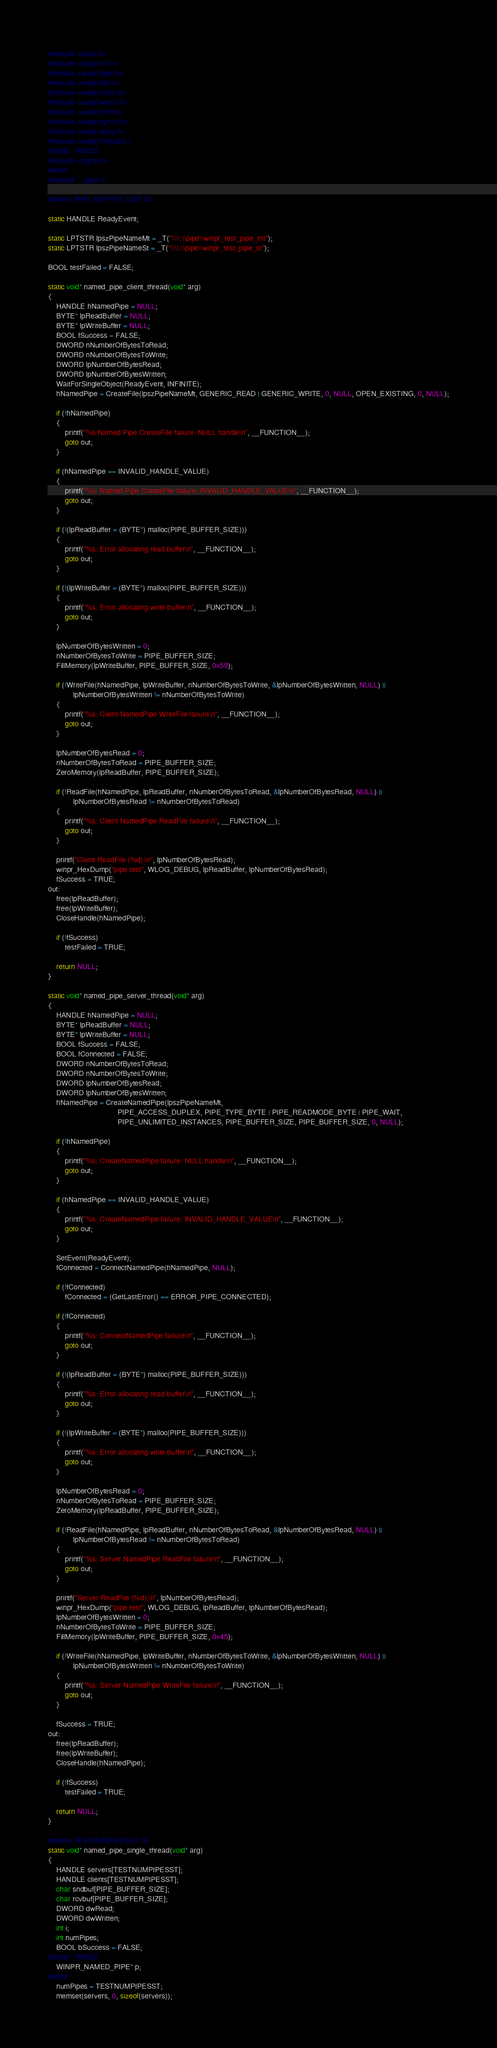<code> <loc_0><loc_0><loc_500><loc_500><_C_>
#include <stdio.h>
#include <winpr/crt.h>
#include <winpr/pipe.h>
#include <winpr/file.h>
#include <winpr/tchar.h>
#include <winpr/winpr.h>
#include <winpr/print.h>
#include <winpr/synch.h>
#include <winpr/wlog.h>
#include <winpr/thread.h>
#ifndef _WIN32
#include <signal.h>
#endif
#include "../pipe.h"

#define PIPE_BUFFER_SIZE	32

static HANDLE ReadyEvent;

static LPTSTR lpszPipeNameMt = _T("\\\\.\\pipe\\winpr_test_pipe_mt");
static LPTSTR lpszPipeNameSt = _T("\\\\.\\pipe\\winpr_test_pipe_st");

BOOL testFailed = FALSE;

static void* named_pipe_client_thread(void* arg)
{
	HANDLE hNamedPipe = NULL;
	BYTE* lpReadBuffer = NULL;
	BYTE* lpWriteBuffer = NULL;
	BOOL fSuccess = FALSE;
	DWORD nNumberOfBytesToRead;
	DWORD nNumberOfBytesToWrite;
	DWORD lpNumberOfBytesRead;
	DWORD lpNumberOfBytesWritten;
	WaitForSingleObject(ReadyEvent, INFINITE);
	hNamedPipe = CreateFile(lpszPipeNameMt, GENERIC_READ | GENERIC_WRITE, 0, NULL, OPEN_EXISTING, 0, NULL);

	if (!hNamedPipe)
	{
		printf("%s:Named Pipe CreateFile failure: NULL handle\n", __FUNCTION__);
		goto out;
	}

	if (hNamedPipe == INVALID_HANDLE_VALUE)
	{
		printf("%s: Named Pipe CreateFile failure: INVALID_HANDLE_VALUE\n", __FUNCTION__);
		goto out;
	}

	if (!(lpReadBuffer = (BYTE*) malloc(PIPE_BUFFER_SIZE)))
	{
		printf("%s: Error allocating read buffer\n", __FUNCTION__);
		goto out;
	}

	if (!(lpWriteBuffer = (BYTE*) malloc(PIPE_BUFFER_SIZE)))
	{
		printf("%s: Error allocating write buffer\n", __FUNCTION__);
		goto out;
	}

	lpNumberOfBytesWritten = 0;
	nNumberOfBytesToWrite = PIPE_BUFFER_SIZE;
	FillMemory(lpWriteBuffer, PIPE_BUFFER_SIZE, 0x59);

	if (!WriteFile(hNamedPipe, lpWriteBuffer, nNumberOfBytesToWrite, &lpNumberOfBytesWritten, NULL) ||
			lpNumberOfBytesWritten != nNumberOfBytesToWrite)
	{
		printf("%s: Client NamedPipe WriteFile failure\n", __FUNCTION__);
		goto out;
	}

	lpNumberOfBytesRead = 0;
	nNumberOfBytesToRead = PIPE_BUFFER_SIZE;
	ZeroMemory(lpReadBuffer, PIPE_BUFFER_SIZE);

	if (!ReadFile(hNamedPipe, lpReadBuffer, nNumberOfBytesToRead, &lpNumberOfBytesRead, NULL) ||
			lpNumberOfBytesRead != nNumberOfBytesToRead)
	{
		printf("%s: Client NamedPipe ReadFile failure\n", __FUNCTION__);
		goto out;
	}

	printf("Client ReadFile (%d):\n", lpNumberOfBytesRead);
	winpr_HexDump("pipe.test", WLOG_DEBUG, lpReadBuffer, lpNumberOfBytesRead);
	fSuccess = TRUE;
out:
	free(lpReadBuffer);
	free(lpWriteBuffer);
	CloseHandle(hNamedPipe);

	if (!fSuccess)
		testFailed = TRUE;

	return NULL;
}

static void* named_pipe_server_thread(void* arg)
{
	HANDLE hNamedPipe = NULL;
	BYTE* lpReadBuffer = NULL;
	BYTE* lpWriteBuffer = NULL;
	BOOL fSuccess = FALSE;
	BOOL fConnected = FALSE;
	DWORD nNumberOfBytesToRead;
	DWORD nNumberOfBytesToWrite;
	DWORD lpNumberOfBytesRead;
	DWORD lpNumberOfBytesWritten;
	hNamedPipe = CreateNamedPipe(lpszPipeNameMt,
								 PIPE_ACCESS_DUPLEX, PIPE_TYPE_BYTE | PIPE_READMODE_BYTE | PIPE_WAIT,
								 PIPE_UNLIMITED_INSTANCES, PIPE_BUFFER_SIZE, PIPE_BUFFER_SIZE, 0, NULL);

	if (!hNamedPipe)
	{
		printf("%s: CreateNamedPipe failure: NULL handle\n", __FUNCTION__);
		goto out;
	}

	if (hNamedPipe == INVALID_HANDLE_VALUE)
	{
		printf("%s: CreateNamedPipe failure: INVALID_HANDLE_VALUE\n", __FUNCTION__);
		goto out;
	}

	SetEvent(ReadyEvent);
	fConnected = ConnectNamedPipe(hNamedPipe, NULL);

	if (!fConnected)
		fConnected = (GetLastError() == ERROR_PIPE_CONNECTED);

	if (!fConnected)
	{
		printf("%s: ConnectNamedPipe failure\n", __FUNCTION__);
		goto out;
	}

	if (!(lpReadBuffer = (BYTE*) malloc(PIPE_BUFFER_SIZE)))
	{
		printf("%s: Error allocating read buffer\n", __FUNCTION__);
		goto out;
	}

	if (!(lpWriteBuffer = (BYTE*) malloc(PIPE_BUFFER_SIZE)))
	{
		printf("%s: Error allocating write buffer\n", __FUNCTION__);
		goto out;
	}

	lpNumberOfBytesRead = 0;
	nNumberOfBytesToRead = PIPE_BUFFER_SIZE;
	ZeroMemory(lpReadBuffer, PIPE_BUFFER_SIZE);

	if (!ReadFile(hNamedPipe, lpReadBuffer, nNumberOfBytesToRead, &lpNumberOfBytesRead, NULL) ||
			lpNumberOfBytesRead != nNumberOfBytesToRead)
	{
		printf("%s: Server NamedPipe ReadFile failure\n", __FUNCTION__);
		goto out;
	}

	printf("Server ReadFile (%d):\n", lpNumberOfBytesRead);
	winpr_HexDump("pipe.test", WLOG_DEBUG, lpReadBuffer, lpNumberOfBytesRead);
	lpNumberOfBytesWritten = 0;
	nNumberOfBytesToWrite = PIPE_BUFFER_SIZE;
	FillMemory(lpWriteBuffer, PIPE_BUFFER_SIZE, 0x45);

	if (!WriteFile(hNamedPipe, lpWriteBuffer, nNumberOfBytesToWrite, &lpNumberOfBytesWritten, NULL) ||
			lpNumberOfBytesWritten != nNumberOfBytesToWrite)
	{
		printf("%s: Server NamedPipe WriteFile failure\n", __FUNCTION__);
		goto out;
	}

	fSuccess = TRUE;
out:
	free(lpReadBuffer);
	free(lpWriteBuffer);
	CloseHandle(hNamedPipe);

	if (!fSuccess)
		testFailed = TRUE;

	return NULL;
}

#define TESTNUMPIPESST 16
static void* named_pipe_single_thread(void* arg)
{
	HANDLE servers[TESTNUMPIPESST];
	HANDLE clients[TESTNUMPIPESST];
	char sndbuf[PIPE_BUFFER_SIZE];
	char rcvbuf[PIPE_BUFFER_SIZE];
	DWORD dwRead;
	DWORD dwWritten;
	int i;
	int numPipes;
	BOOL bSuccess = FALSE;
#ifndef _WIN32
	WINPR_NAMED_PIPE* p;
#endif
	numPipes = TESTNUMPIPESST;
	memset(servers, 0, sizeof(servers));</code> 